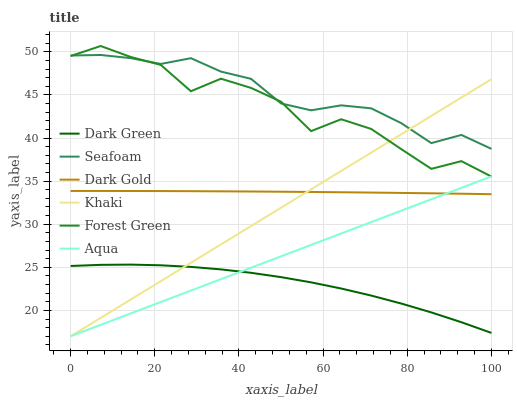Does Dark Green have the minimum area under the curve?
Answer yes or no. Yes. Does Seafoam have the maximum area under the curve?
Answer yes or no. Yes. Does Dark Gold have the minimum area under the curve?
Answer yes or no. No. Does Dark Gold have the maximum area under the curve?
Answer yes or no. No. Is Aqua the smoothest?
Answer yes or no. Yes. Is Forest Green the roughest?
Answer yes or no. Yes. Is Dark Gold the smoothest?
Answer yes or no. No. Is Dark Gold the roughest?
Answer yes or no. No. Does Khaki have the lowest value?
Answer yes or no. Yes. Does Dark Gold have the lowest value?
Answer yes or no. No. Does Forest Green have the highest value?
Answer yes or no. Yes. Does Dark Gold have the highest value?
Answer yes or no. No. Is Dark Gold less than Seafoam?
Answer yes or no. Yes. Is Forest Green greater than Dark Green?
Answer yes or no. Yes. Does Seafoam intersect Forest Green?
Answer yes or no. Yes. Is Seafoam less than Forest Green?
Answer yes or no. No. Is Seafoam greater than Forest Green?
Answer yes or no. No. Does Dark Gold intersect Seafoam?
Answer yes or no. No. 